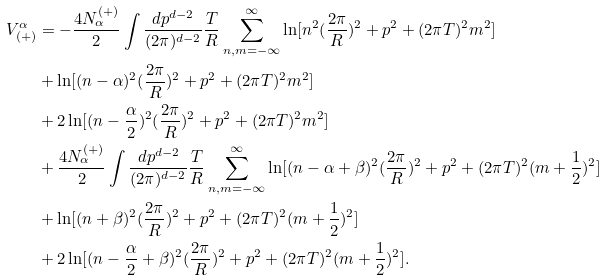Convert formula to latex. <formula><loc_0><loc_0><loc_500><loc_500>V _ { ( + ) } ^ { \alpha } & = - \frac { 4 N ^ { ( + ) } _ { \alpha } } { 2 } \int \frac { d p ^ { d - 2 } } { ( 2 \pi ) ^ { d - 2 } } \frac { T } { R } \sum _ { n , m = - \infty } ^ { \infty } \ln [ n ^ { 2 } ( \frac { 2 \pi } { R } ) ^ { 2 } + p ^ { 2 } + ( 2 \pi { T } ) ^ { 2 } m ^ { 2 } ] \\ & + \ln [ ( n - \alpha ) ^ { 2 } ( \frac { 2 \pi } { R } ) ^ { 2 } + p ^ { 2 } + ( 2 \pi { T } ) ^ { 2 } m ^ { 2 } ] \\ & + 2 \ln [ ( n - \frac { \alpha } { 2 } ) ^ { 2 } ( \frac { 2 \pi } { R } ) ^ { 2 } + p ^ { 2 } + ( 2 \pi { T } ) ^ { 2 } m ^ { 2 } ] \\ & + \frac { 4 N ^ { ( + ) } _ { \alpha } } { 2 } \int \frac { d p ^ { d - 2 } } { ( 2 \pi ) ^ { d - 2 } } \frac { T } { R } \sum _ { n , m = - \infty } ^ { \infty } \ln [ ( n - \alpha + \beta ) ^ { 2 } ( \frac { 2 \pi } { R } ) ^ { 2 } + p ^ { 2 } + ( 2 \pi { T } ) ^ { 2 } ( m + \frac { 1 } { 2 } ) ^ { 2 } ] \\ & + \ln [ ( n + \beta ) ^ { 2 } ( \frac { 2 \pi } { R } ) ^ { 2 } + p ^ { 2 } + ( 2 \pi { T } ) ^ { 2 } ( m + \frac { 1 } { 2 } ) ^ { 2 } ] \\ & + 2 \ln [ ( n - \frac { \alpha } { 2 } + \beta ) ^ { 2 } ( \frac { 2 \pi } { R } ) ^ { 2 } + p ^ { 2 } + ( 2 \pi { T } ) ^ { 2 } ( m + \frac { 1 } { 2 } ) ^ { 2 } ] .</formula> 